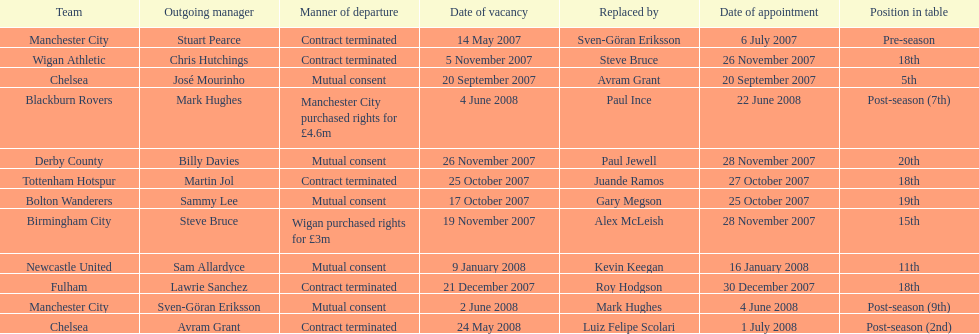Which outgoing manager was appointed the last? Mark Hughes. 